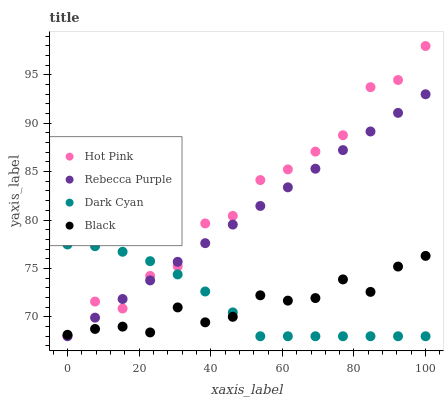Does Black have the minimum area under the curve?
Answer yes or no. Yes. Does Hot Pink have the maximum area under the curve?
Answer yes or no. Yes. Does Hot Pink have the minimum area under the curve?
Answer yes or no. No. Does Black have the maximum area under the curve?
Answer yes or no. No. Is Rebecca Purple the smoothest?
Answer yes or no. Yes. Is Hot Pink the roughest?
Answer yes or no. Yes. Is Black the smoothest?
Answer yes or no. No. Is Black the roughest?
Answer yes or no. No. Does Dark Cyan have the lowest value?
Answer yes or no. Yes. Does Hot Pink have the lowest value?
Answer yes or no. No. Does Hot Pink have the highest value?
Answer yes or no. Yes. Does Black have the highest value?
Answer yes or no. No. Does Black intersect Rebecca Purple?
Answer yes or no. Yes. Is Black less than Rebecca Purple?
Answer yes or no. No. Is Black greater than Rebecca Purple?
Answer yes or no. No. 